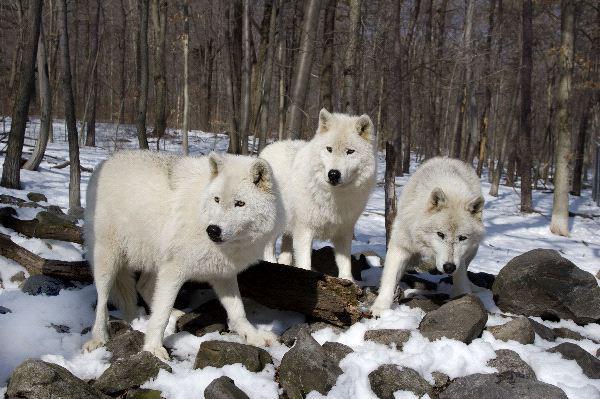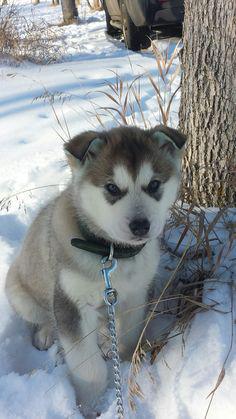The first image is the image on the left, the second image is the image on the right. Assess this claim about the two images: "In at least one image there are two pairs of dogs looking in different directions.". Correct or not? Answer yes or no. No. 